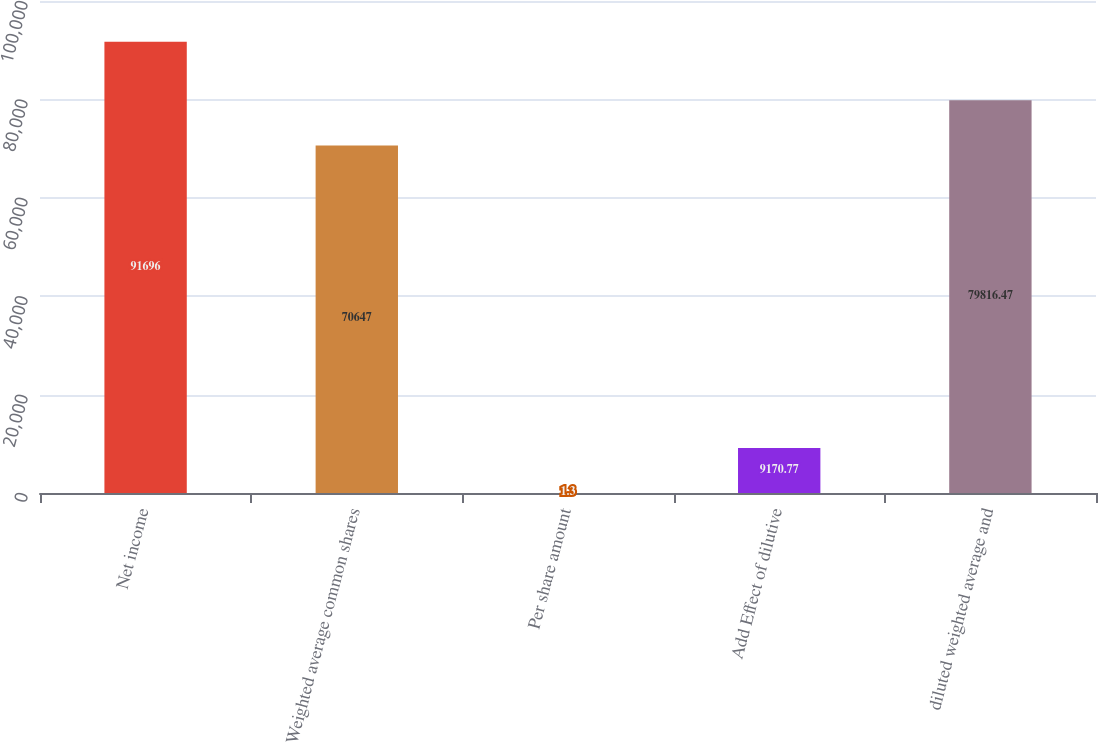Convert chart to OTSL. <chart><loc_0><loc_0><loc_500><loc_500><bar_chart><fcel>Net income<fcel>Weighted average common shares<fcel>Per share amount<fcel>Add Effect of dilutive<fcel>diluted weighted average and<nl><fcel>91696<fcel>70647<fcel>1.3<fcel>9170.77<fcel>79816.5<nl></chart> 